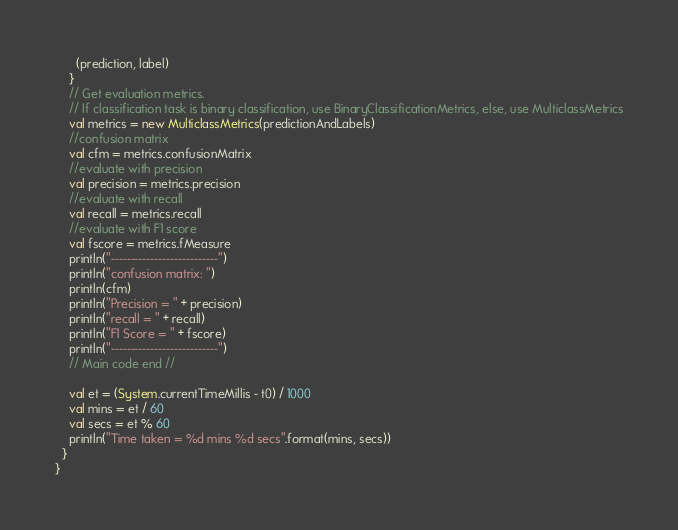<code> <loc_0><loc_0><loc_500><loc_500><_Scala_>      (prediction, label)
    }
    // Get evaluation metrics.
    // If classification task is binary classification, use BinaryClassificationMetrics, else, use MulticlassMetrics
    val metrics = new MulticlassMetrics(predictionAndLabels)
    //confusion matrix
    val cfm = metrics.confusionMatrix
    //evaluate with precision
    val precision = metrics.precision
    //evaluate with recall
    val recall = metrics.recall
    //evaluate with F1 score
    val fscore = metrics.fMeasure
    println("---------------------------")
    println("confusion matrix: ")
    println(cfm)
    println("Precision = " + precision)
    println("recall = " + recall)
    println("F1 Score = " + fscore)
    println("---------------------------")
    // Main code end //

    val et = (System.currentTimeMillis - t0) / 1000
    val mins = et / 60
    val secs = et % 60
    println("Time taken = %d mins %d secs".format(mins, secs))
  }
}</code> 